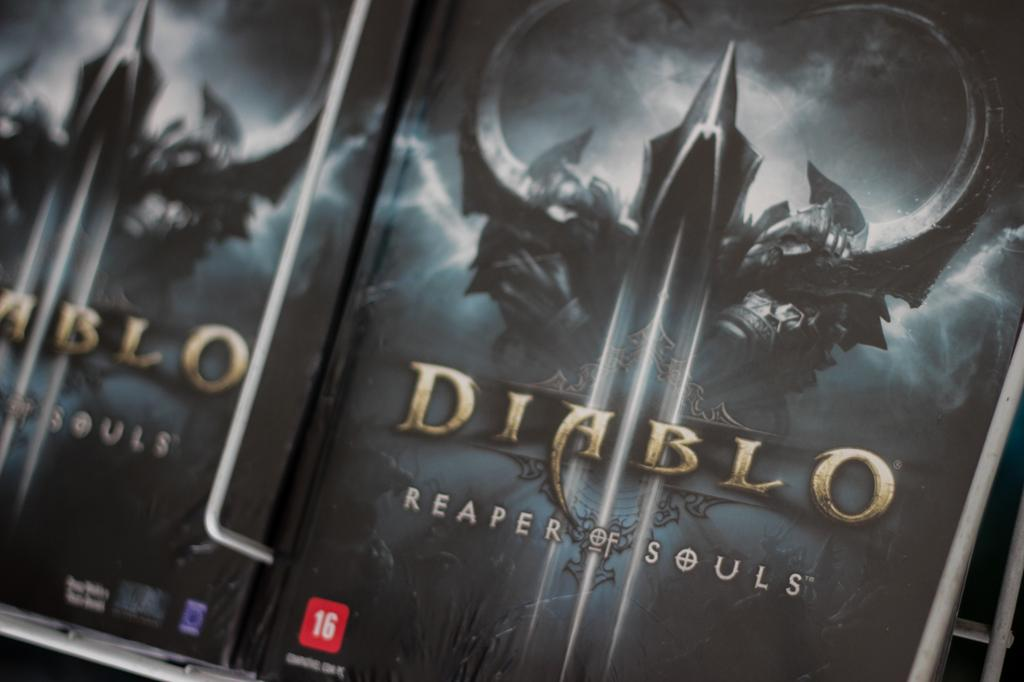<image>
Present a compact description of the photo's key features. A Diablo  3 case with a game in it 